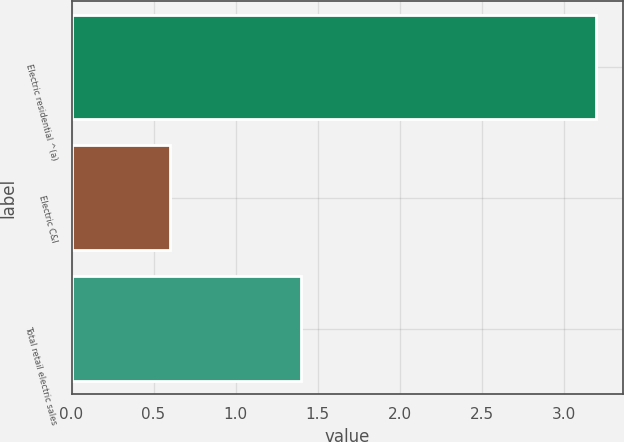Convert chart. <chart><loc_0><loc_0><loc_500><loc_500><bar_chart><fcel>Electric residential ^(a)<fcel>Electric C&I<fcel>Total retail electric sales<nl><fcel>3.2<fcel>0.6<fcel>1.4<nl></chart> 